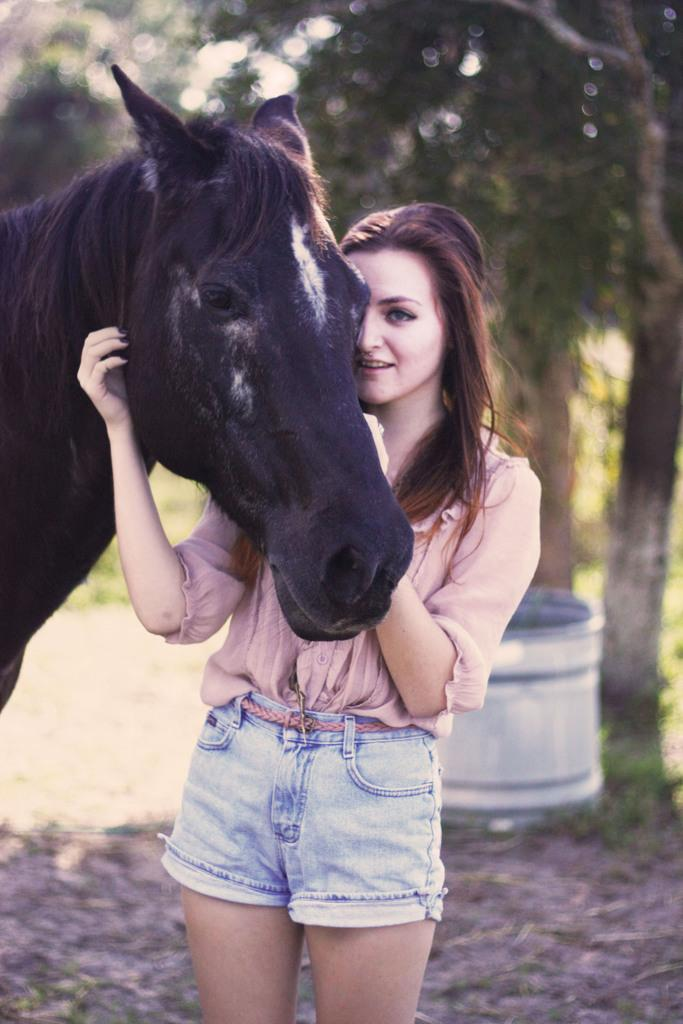Who is the main subject in the image? There is a lady in the image. What is the lady wearing? The lady is wearing a pink shirt. What is the lady doing in the image? The lady is touching a horse. What can be seen in the background of the image? There are trees in the background of the image. What type of feast is being prepared in the image? There is no indication of a feast being prepared in the image; it features a lady touching a horse with trees in the background. 